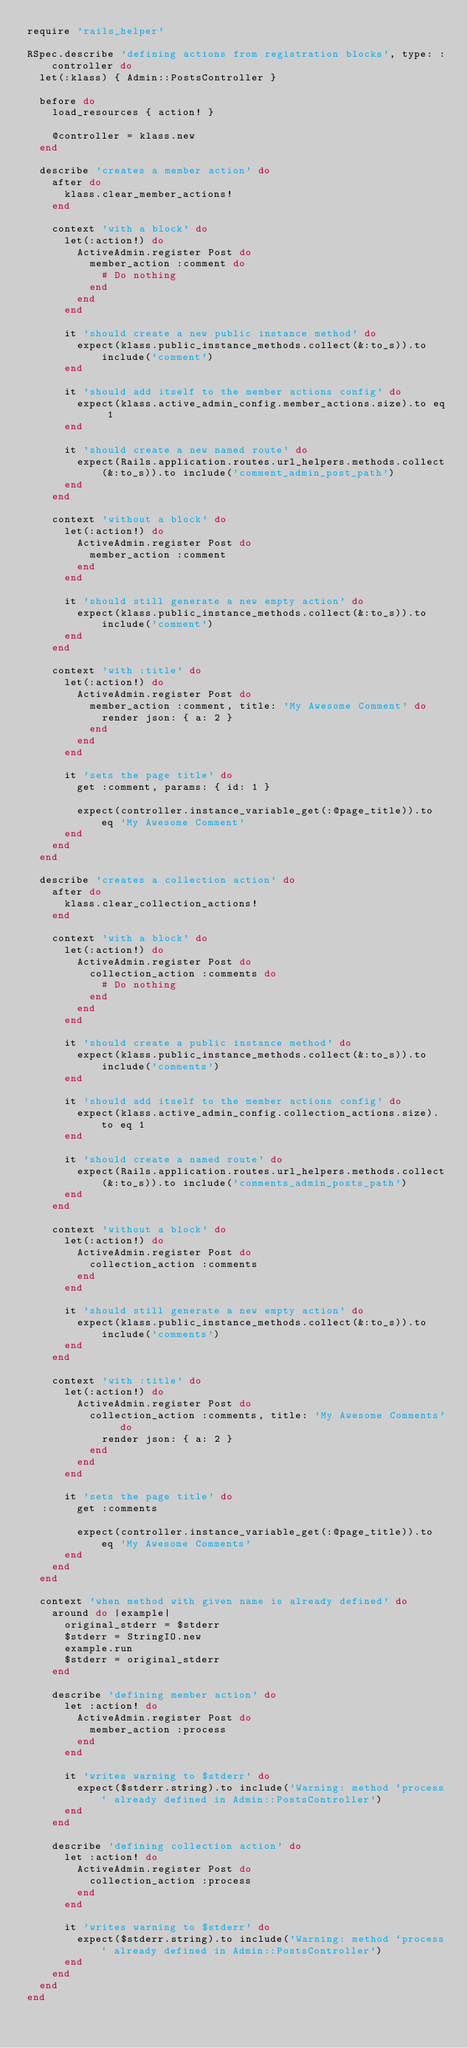Convert code to text. <code><loc_0><loc_0><loc_500><loc_500><_Ruby_>require 'rails_helper'

RSpec.describe 'defining actions from registration blocks', type: :controller do
  let(:klass) { Admin::PostsController }

  before do
    load_resources { action! }

    @controller = klass.new
  end

  describe 'creates a member action' do
    after do
      klass.clear_member_actions!
    end

    context 'with a block' do
      let(:action!) do
        ActiveAdmin.register Post do
          member_action :comment do
            # Do nothing
          end
        end
      end

      it 'should create a new public instance method' do
        expect(klass.public_instance_methods.collect(&:to_s)).to include('comment')
      end

      it 'should add itself to the member actions config' do
        expect(klass.active_admin_config.member_actions.size).to eq 1
      end

      it 'should create a new named route' do
        expect(Rails.application.routes.url_helpers.methods.collect(&:to_s)).to include('comment_admin_post_path')
      end
    end

    context 'without a block' do
      let(:action!) do
        ActiveAdmin.register Post do
          member_action :comment
        end
      end

      it 'should still generate a new empty action' do
        expect(klass.public_instance_methods.collect(&:to_s)).to include('comment')
      end
    end

    context 'with :title' do
      let(:action!) do
        ActiveAdmin.register Post do
          member_action :comment, title: 'My Awesome Comment' do
            render json: { a: 2 }
          end
        end
      end

      it 'sets the page title' do
        get :comment, params: { id: 1 }

        expect(controller.instance_variable_get(:@page_title)).to eq 'My Awesome Comment'
      end
    end
  end

  describe 'creates a collection action' do
    after do
      klass.clear_collection_actions!
    end

    context 'with a block' do
      let(:action!) do
        ActiveAdmin.register Post do
          collection_action :comments do
            # Do nothing
          end
        end
      end

      it 'should create a public instance method' do
        expect(klass.public_instance_methods.collect(&:to_s)).to include('comments')
      end

      it 'should add itself to the member actions config' do
        expect(klass.active_admin_config.collection_actions.size).to eq 1
      end

      it 'should create a named route' do
        expect(Rails.application.routes.url_helpers.methods.collect(&:to_s)).to include('comments_admin_posts_path')
      end
    end

    context 'without a block' do
      let(:action!) do
        ActiveAdmin.register Post do
          collection_action :comments
        end
      end

      it 'should still generate a new empty action' do
        expect(klass.public_instance_methods.collect(&:to_s)).to include('comments')
      end
    end

    context 'with :title' do
      let(:action!) do
        ActiveAdmin.register Post do
          collection_action :comments, title: 'My Awesome Comments' do
            render json: { a: 2 }
          end
        end
      end

      it 'sets the page title' do
        get :comments

        expect(controller.instance_variable_get(:@page_title)).to eq 'My Awesome Comments'
      end
    end
  end

  context 'when method with given name is already defined' do
    around do |example|
      original_stderr = $stderr
      $stderr = StringIO.new
      example.run
      $stderr = original_stderr
    end

    describe 'defining member action' do
      let :action! do
        ActiveAdmin.register Post do
          member_action :process
        end
      end

      it 'writes warning to $stderr' do
        expect($stderr.string).to include('Warning: method `process` already defined in Admin::PostsController')
      end
    end

    describe 'defining collection action' do
      let :action! do
        ActiveAdmin.register Post do
          collection_action :process
        end
      end

      it 'writes warning to $stderr' do
        expect($stderr.string).to include('Warning: method `process` already defined in Admin::PostsController')
      end
    end
  end
end
</code> 